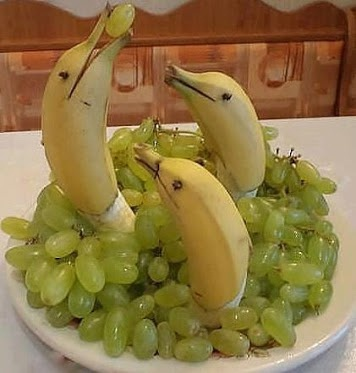Describe the objects in this image and their specific colors. I can see dining table in gray and olive tones, banana in gray, olive, and tan tones, and banana in gray, tan, and olive tones in this image. 